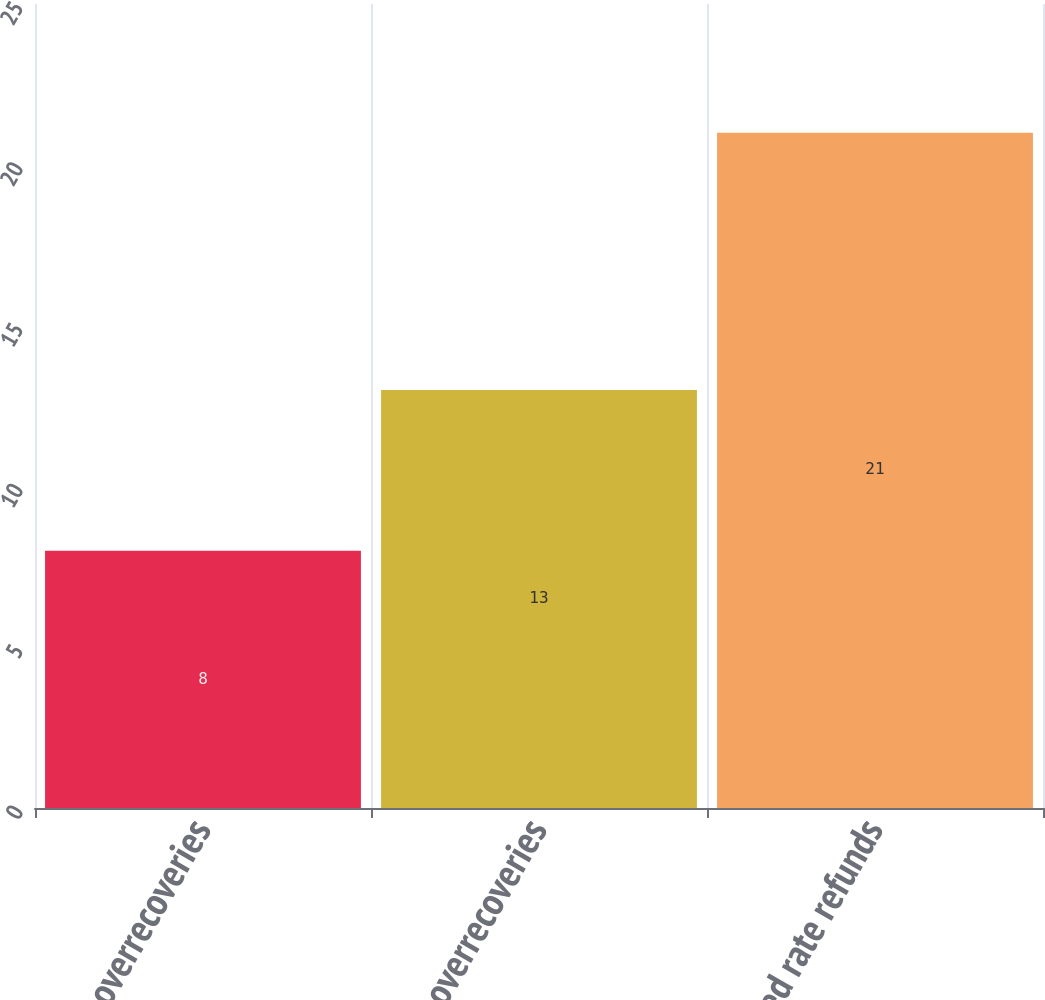<chart> <loc_0><loc_0><loc_500><loc_500><bar_chart><fcel>PSCR overrecoveries<fcel>GCR overrecoveries<fcel>Accrued rate refunds<nl><fcel>8<fcel>13<fcel>21<nl></chart> 